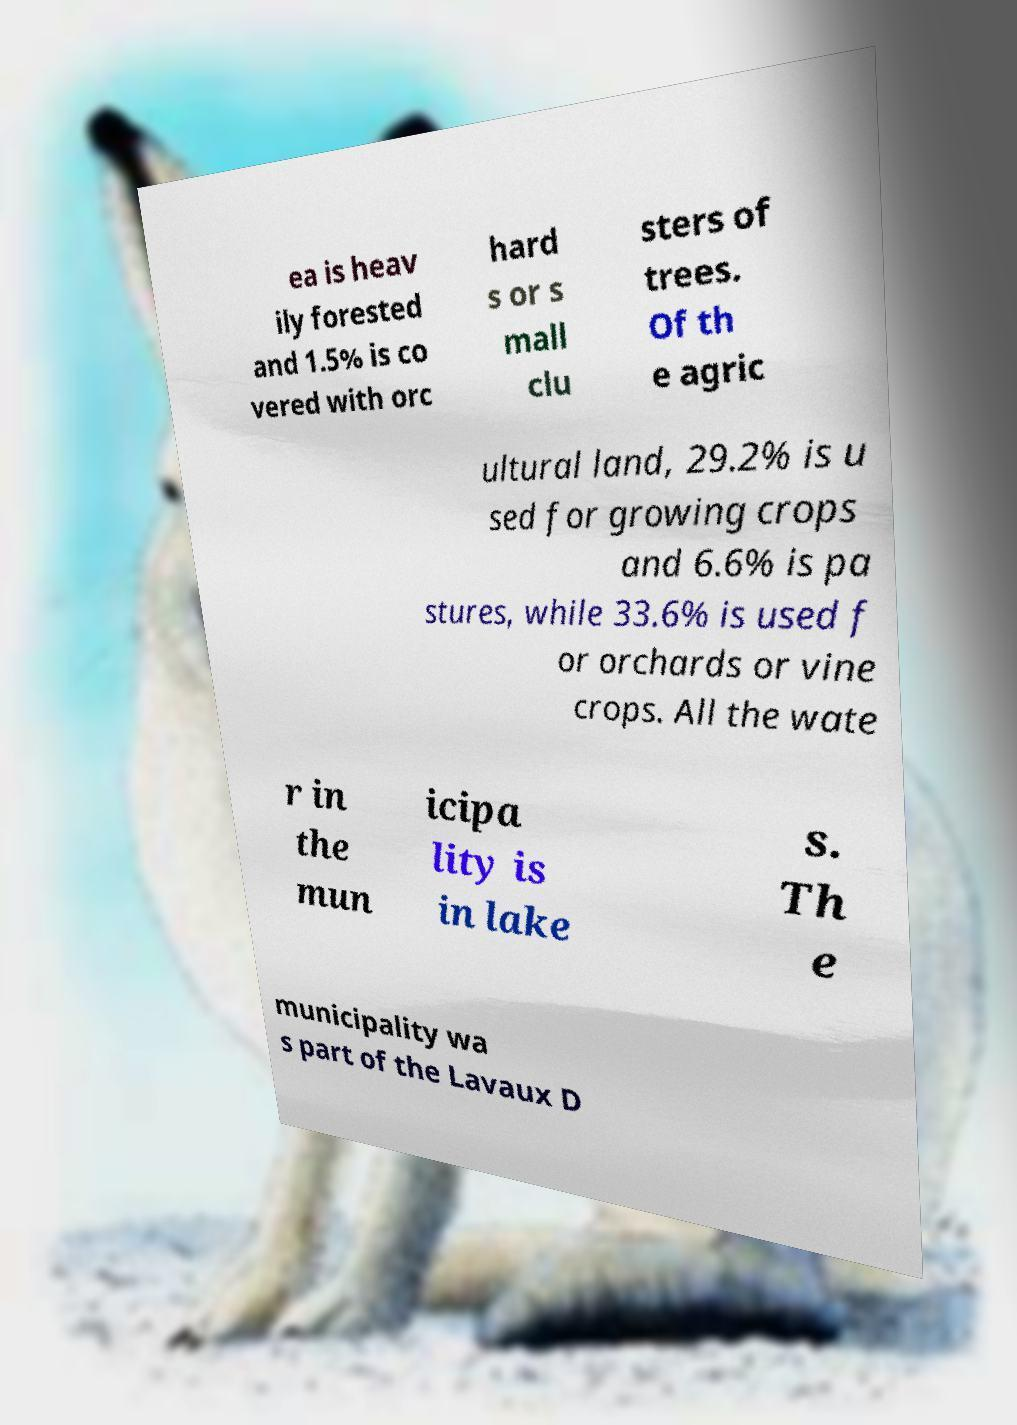What messages or text are displayed in this image? I need them in a readable, typed format. ea is heav ily forested and 1.5% is co vered with orc hard s or s mall clu sters of trees. Of th e agric ultural land, 29.2% is u sed for growing crops and 6.6% is pa stures, while 33.6% is used f or orchards or vine crops. All the wate r in the mun icipa lity is in lake s. Th e municipality wa s part of the Lavaux D 